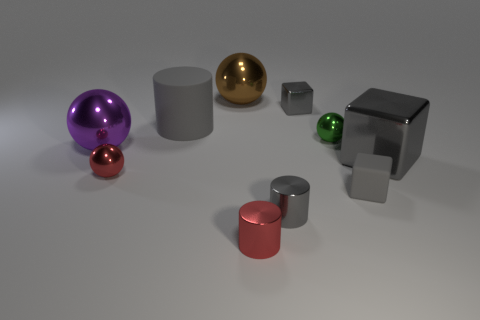Are there any shadows visible that indicate the light source position? Yes, the objects cast soft, diffused shadows on the ground towards the bottom left of the image, implying that the light source is located towards the top right. How does the lighting affect the appearance of the objects? The lighting creates highlights on the objects' surfaces facing the light, enhancing their three-dimensional form. The reflections and shadows give the scene depth and realism. 